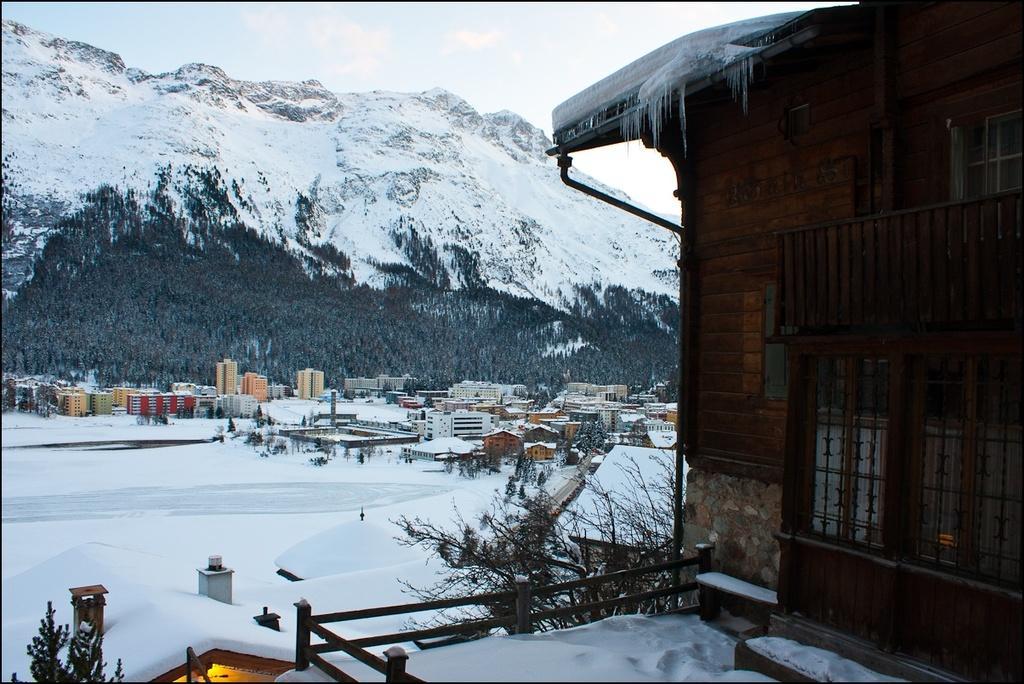Describe this image in one or two sentences. In this picture we can see houses, buildings, trees and snow. Behind the buildings there is a snowy hill and the sky. 